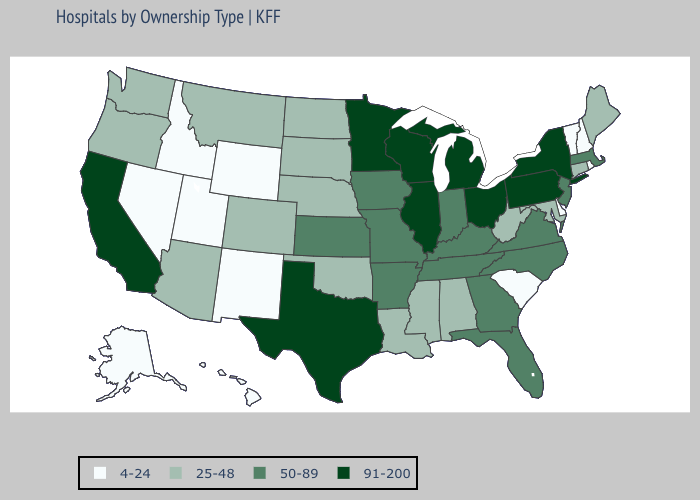Does the first symbol in the legend represent the smallest category?
Give a very brief answer. Yes. Does Alabama have the highest value in the USA?
Concise answer only. No. Name the states that have a value in the range 50-89?
Answer briefly. Arkansas, Florida, Georgia, Indiana, Iowa, Kansas, Kentucky, Massachusetts, Missouri, New Jersey, North Carolina, Tennessee, Virginia. What is the lowest value in the USA?
Answer briefly. 4-24. What is the value of Michigan?
Be succinct. 91-200. Does South Carolina have the lowest value in the South?
Write a very short answer. Yes. Which states hav the highest value in the MidWest?
Keep it brief. Illinois, Michigan, Minnesota, Ohio, Wisconsin. Name the states that have a value in the range 91-200?
Quick response, please. California, Illinois, Michigan, Minnesota, New York, Ohio, Pennsylvania, Texas, Wisconsin. Name the states that have a value in the range 4-24?
Keep it brief. Alaska, Delaware, Hawaii, Idaho, Nevada, New Hampshire, New Mexico, Rhode Island, South Carolina, Utah, Vermont, Wyoming. Which states hav the highest value in the South?
Concise answer only. Texas. What is the value of Nebraska?
Keep it brief. 25-48. How many symbols are there in the legend?
Answer briefly. 4. Among the states that border Georgia , does Alabama have the highest value?
Quick response, please. No. Does New Mexico have the lowest value in the West?
Concise answer only. Yes. What is the lowest value in the MidWest?
Be succinct. 25-48. 